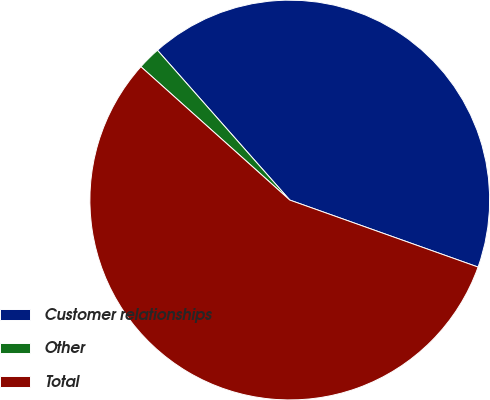Convert chart to OTSL. <chart><loc_0><loc_0><loc_500><loc_500><pie_chart><fcel>Customer relationships<fcel>Other<fcel>Total<nl><fcel>41.96%<fcel>1.86%<fcel>56.19%<nl></chart> 